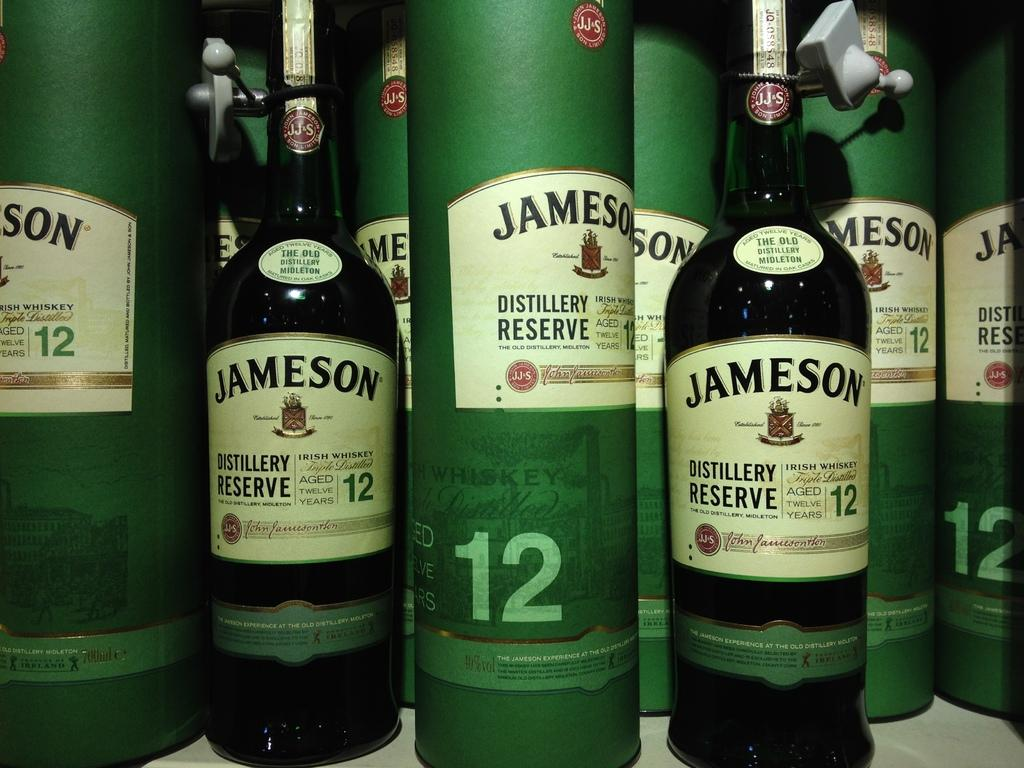<image>
Summarize the visual content of the image. a lot of bottles of jameson are sitting on the table 